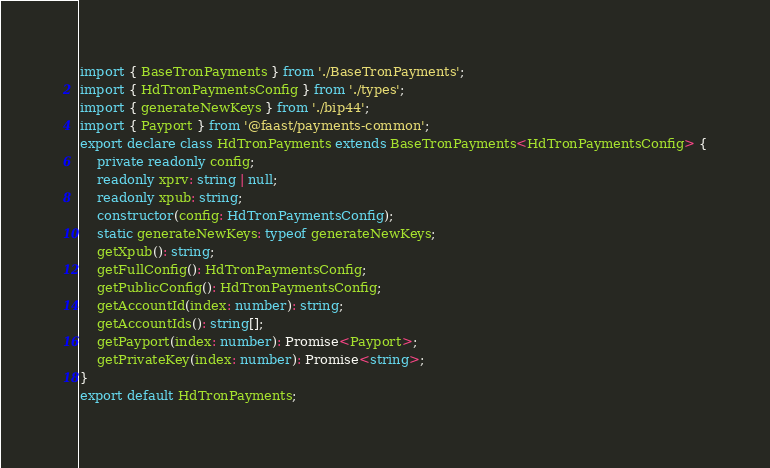Convert code to text. <code><loc_0><loc_0><loc_500><loc_500><_TypeScript_>import { BaseTronPayments } from './BaseTronPayments';
import { HdTronPaymentsConfig } from './types';
import { generateNewKeys } from './bip44';
import { Payport } from '@faast/payments-common';
export declare class HdTronPayments extends BaseTronPayments<HdTronPaymentsConfig> {
    private readonly config;
    readonly xprv: string | null;
    readonly xpub: string;
    constructor(config: HdTronPaymentsConfig);
    static generateNewKeys: typeof generateNewKeys;
    getXpub(): string;
    getFullConfig(): HdTronPaymentsConfig;
    getPublicConfig(): HdTronPaymentsConfig;
    getAccountId(index: number): string;
    getAccountIds(): string[];
    getPayport(index: number): Promise<Payport>;
    getPrivateKey(index: number): Promise<string>;
}
export default HdTronPayments;
</code> 